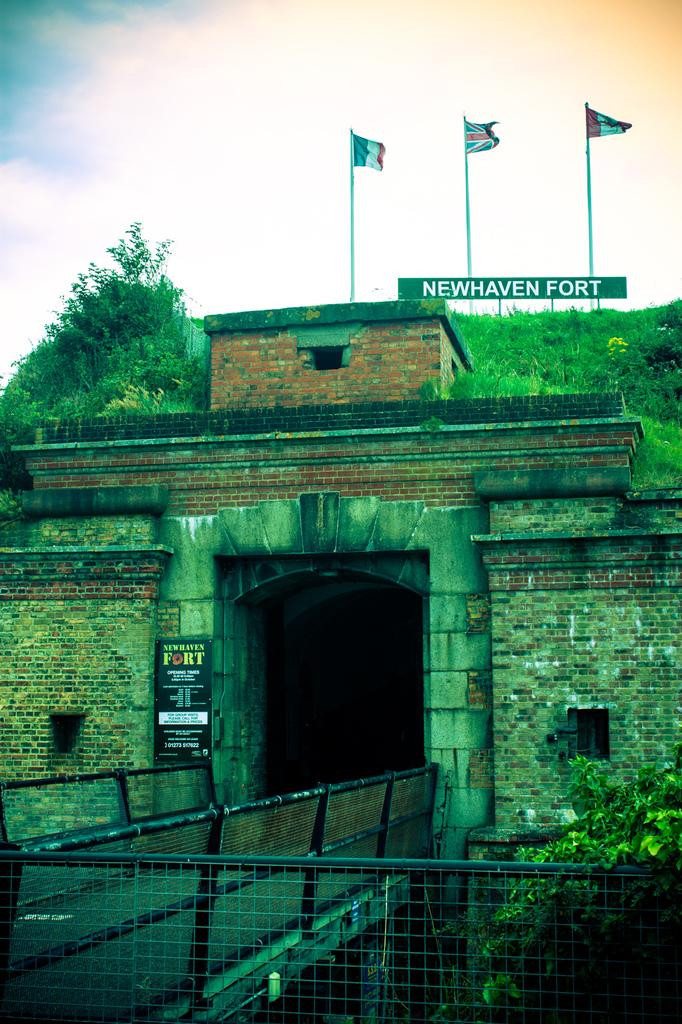What type of structure is present in the image? There is a fort in the image. What type of vegetation can be seen in the image? There are trees in the image. What are the flags associated with in the image? The flags are associated with the fort in the image. What type of material is present in the image? There are boards in the image. What type of architectural feature is present in the image? There is a bridge in the image. What type of barrier is present in the image? There is a mesh in the image. What is visible at the top of the image? The sky is visible at the top of the image. What type of comfort can be seen in the image? There is no reference to comfort in the image; it features a fort, trees, flags, boards, a bridge, a mesh, and the sky. What type of eggnog is being served in the image? There is no eggnog present in the image. What type of paint is being used to decorate the fort in the image? There is no mention of paint or any decoration in the image; it simply shows a fort, trees, flags, boards, a bridge, a mesh, and the sky. 